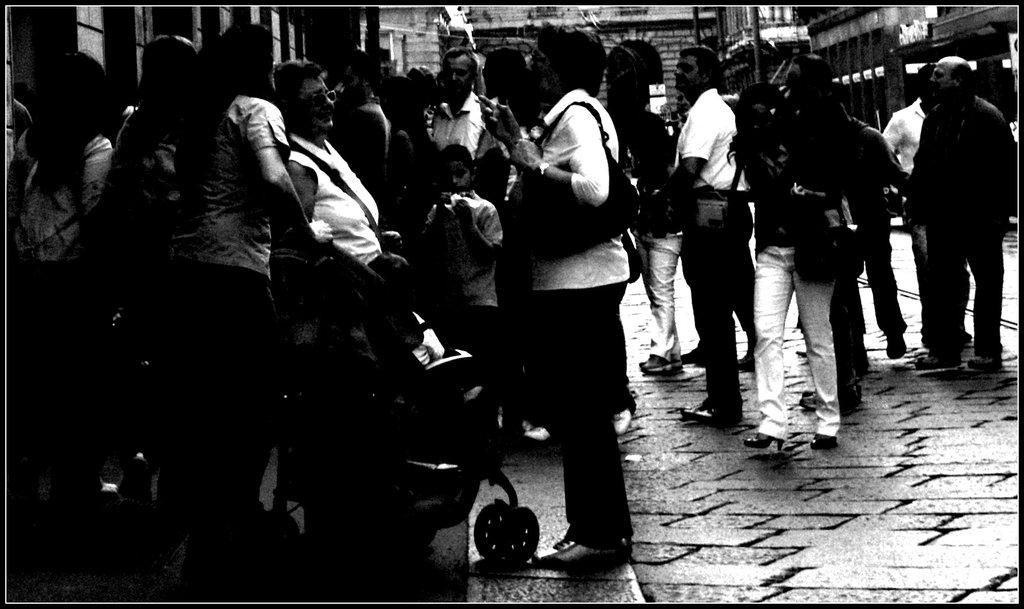What is the color scheme of the image? The image is black and white. Who or what can be seen in the image? There are people in the image. What surface is visible in the image? There is a floor visible in the image. What type of object is present in the image? There is a stroller in the image. What type of structures can be seen in the image? There are buildings in the image. What type of cloth is draped over the buildings in the image? There is no cloth draped over the buildings in the image; it is a black and white image with no visible cloth. 